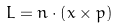<formula> <loc_0><loc_0><loc_500><loc_500>L = { n } \cdot \left ( { x } \times { p } \right )</formula> 